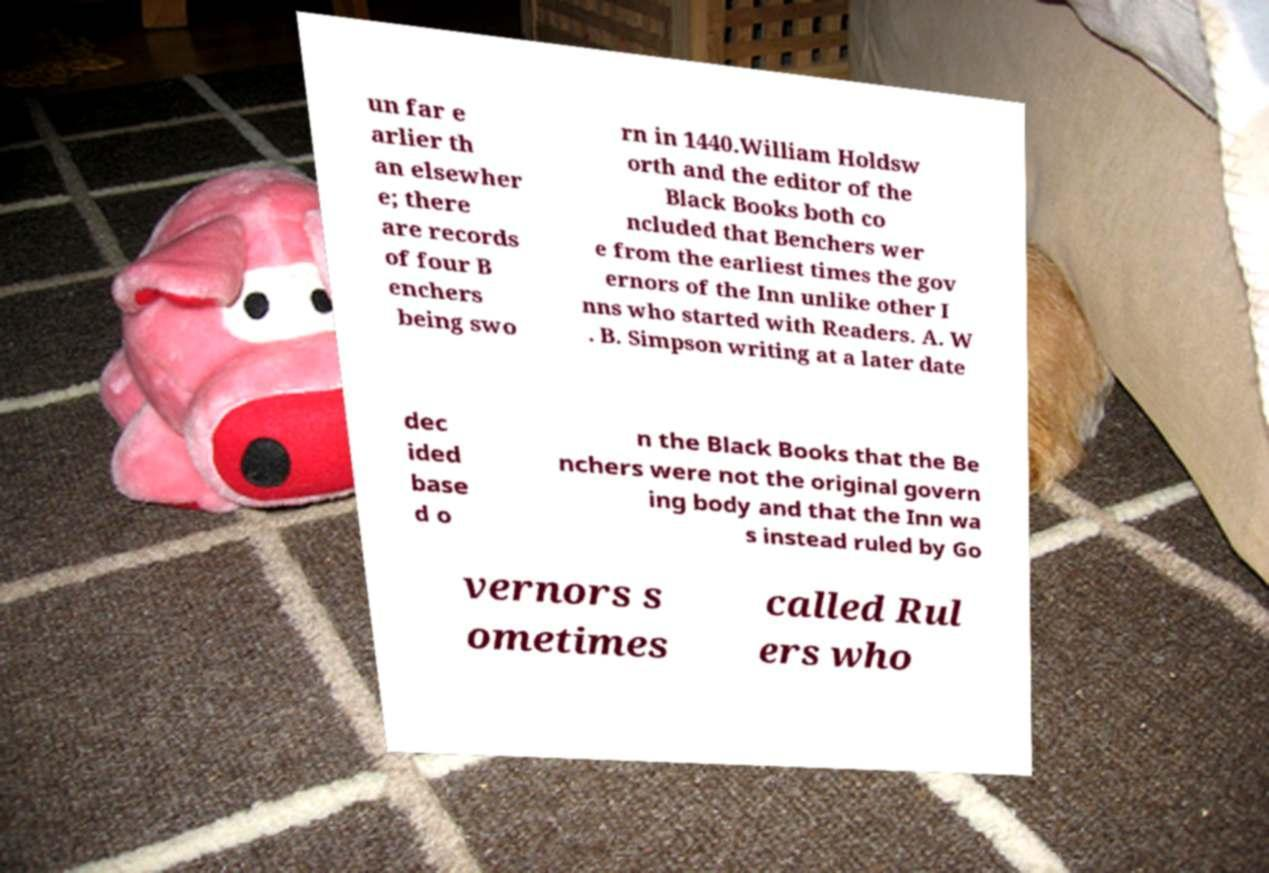Could you extract and type out the text from this image? un far e arlier th an elsewher e; there are records of four B enchers being swo rn in 1440.William Holdsw orth and the editor of the Black Books both co ncluded that Benchers wer e from the earliest times the gov ernors of the Inn unlike other I nns who started with Readers. A. W . B. Simpson writing at a later date dec ided base d o n the Black Books that the Be nchers were not the original govern ing body and that the Inn wa s instead ruled by Go vernors s ometimes called Rul ers who 